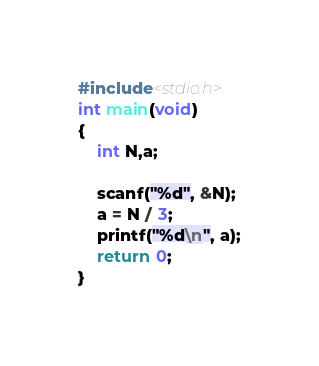<code> <loc_0><loc_0><loc_500><loc_500><_C++_>#include<stdio.h>
int main(void)
{
    int N,a;

    scanf("%d", &N);
    a = N / 3;
    printf("%d\n", a);
    return 0;
}
</code> 